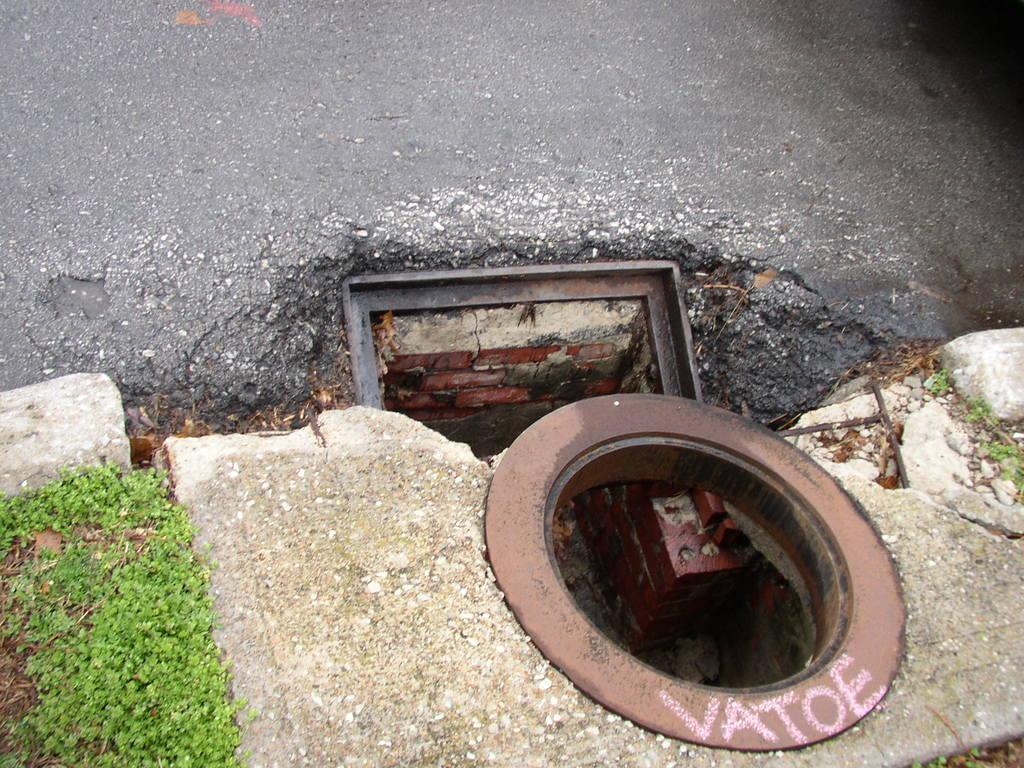In one or two sentences, can you explain what this image depicts? In this picture, we can see some hole, metallic objects and some grass on the road. 